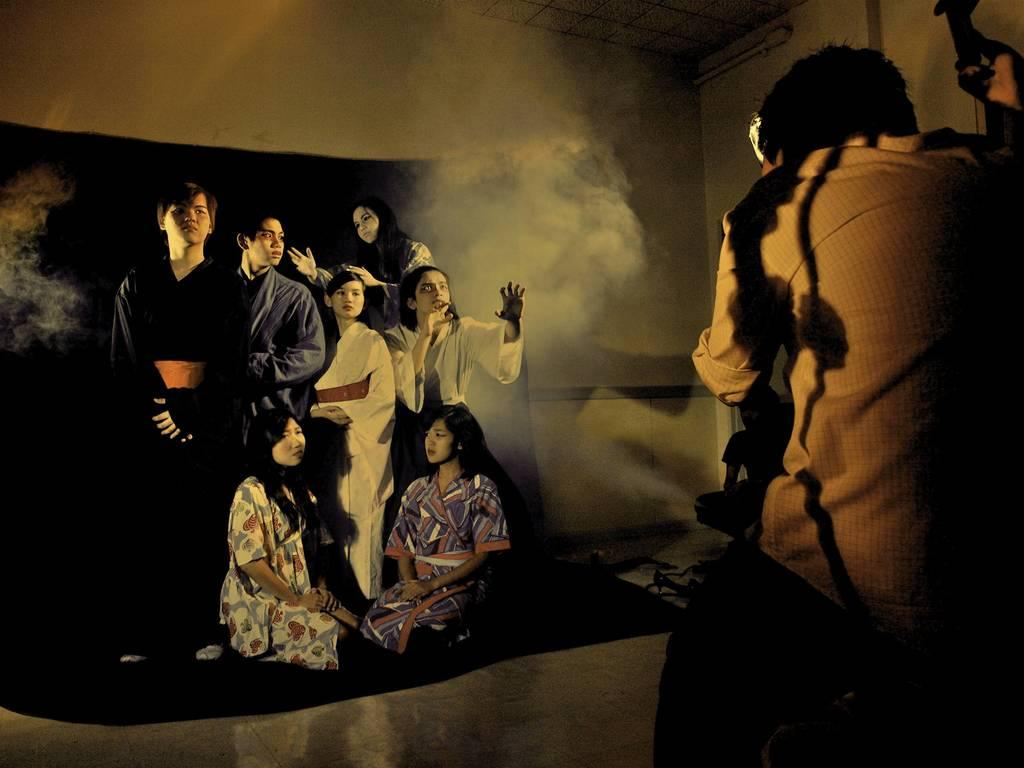Who is the main subject in the image? There is a man in the image. Where is the man located in the image? The man is on the right side of the image. What else can be seen in the background of the image? There are people in the background of the image. What architectural feature is visible at the top of the image? There is a roof visible at the top of the image. What time of day is it in the image, based on the hour hand on the clock? There is no clock present in the image, so it is not possible to determine the time of day based on an hour hand. 